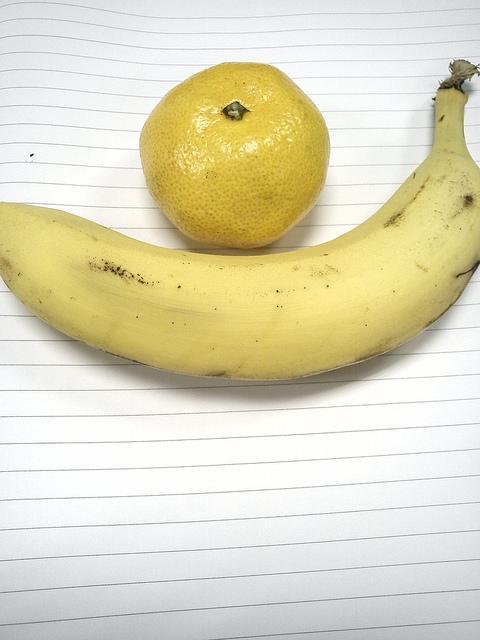How many citrus fruits are there?
Give a very brief answer. 1. How many pieces of fruit are there?
Give a very brief answer. 2. How many people are wearing red?
Give a very brief answer. 0. 